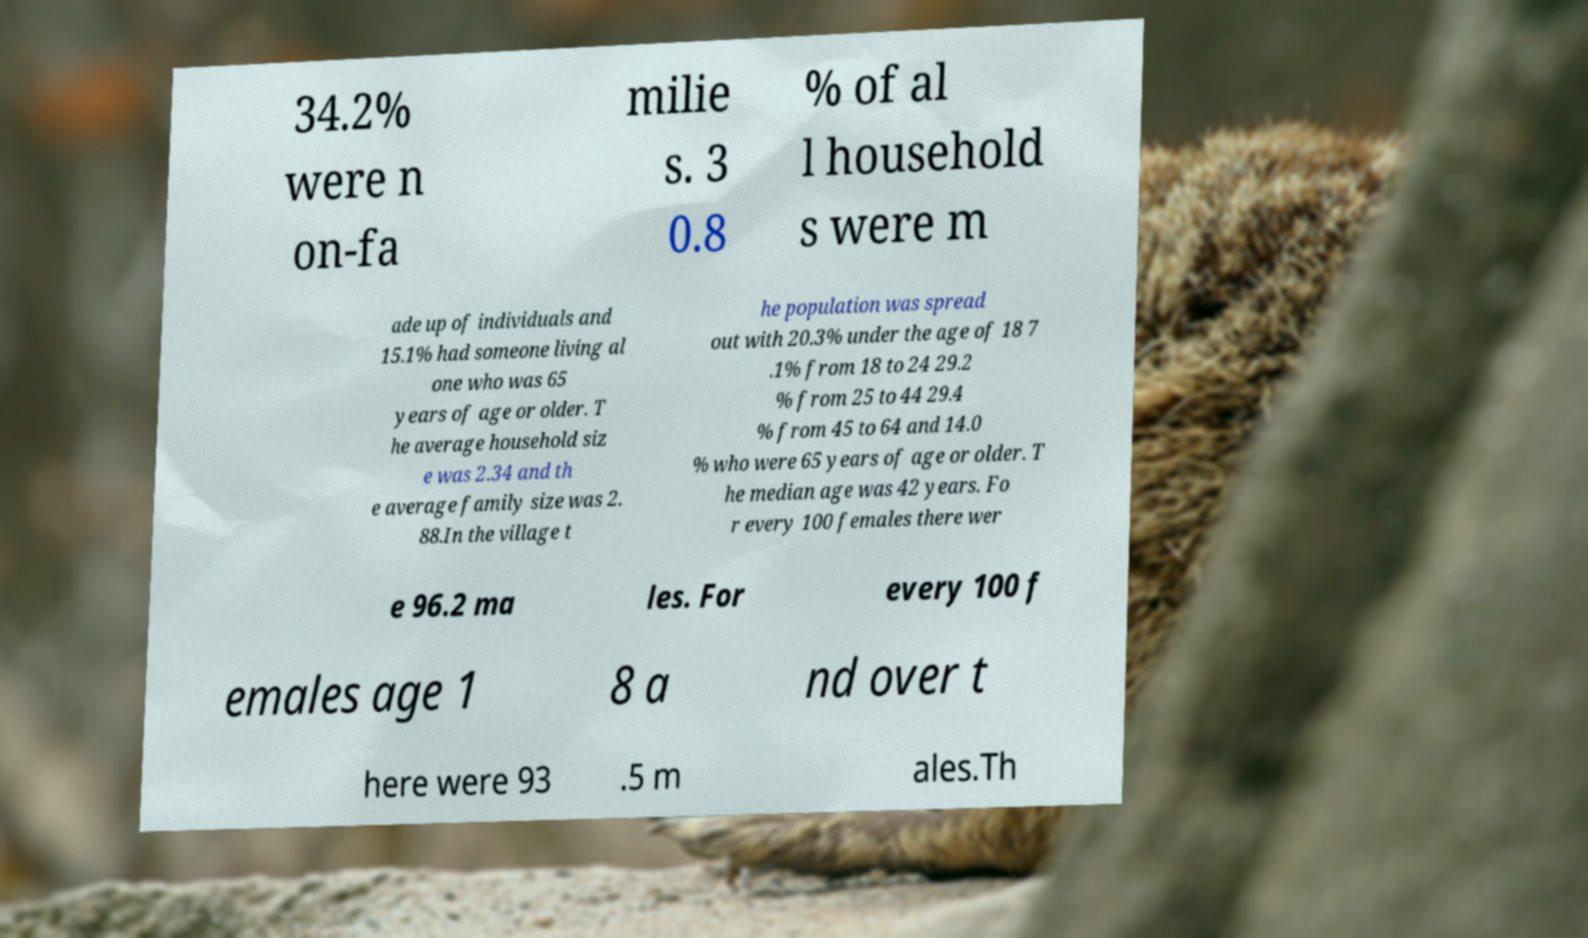Can you read and provide the text displayed in the image?This photo seems to have some interesting text. Can you extract and type it out for me? 34.2% were n on-fa milie s. 3 0.8 % of al l household s were m ade up of individuals and 15.1% had someone living al one who was 65 years of age or older. T he average household siz e was 2.34 and th e average family size was 2. 88.In the village t he population was spread out with 20.3% under the age of 18 7 .1% from 18 to 24 29.2 % from 25 to 44 29.4 % from 45 to 64 and 14.0 % who were 65 years of age or older. T he median age was 42 years. Fo r every 100 females there wer e 96.2 ma les. For every 100 f emales age 1 8 a nd over t here were 93 .5 m ales.Th 